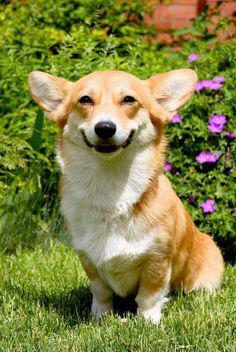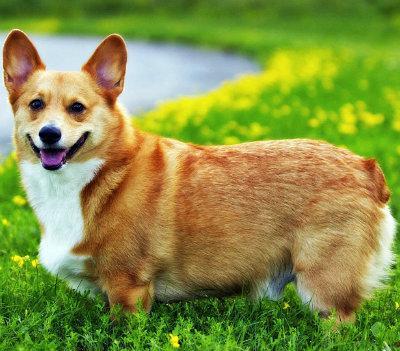The first image is the image on the left, the second image is the image on the right. Assess this claim about the two images: "One image shows a grinning, close-mouthed corgi with ears that splay outward, sitting upright in grass.". Correct or not? Answer yes or no. Yes. The first image is the image on the left, the second image is the image on the right. Given the left and right images, does the statement "There is one corgi sitting in the grass outside and another corgi who is standing in the grass while outside." hold true? Answer yes or no. Yes. 